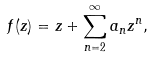<formula> <loc_0><loc_0><loc_500><loc_500>f ( z ) = z + \sum _ { n = 2 } ^ { \infty } a _ { n } z ^ { n } ,</formula> 